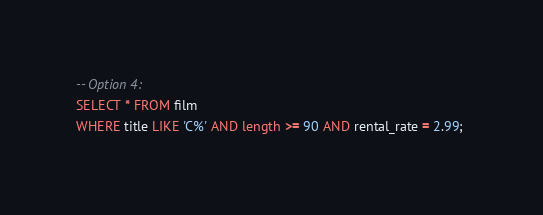Convert code to text. <code><loc_0><loc_0><loc_500><loc_500><_SQL_>
-- Option 4:
SELECT * FROM film
WHERE title LIKE 'C%' AND length >= 90 AND rental_rate = 2.99; 


</code> 